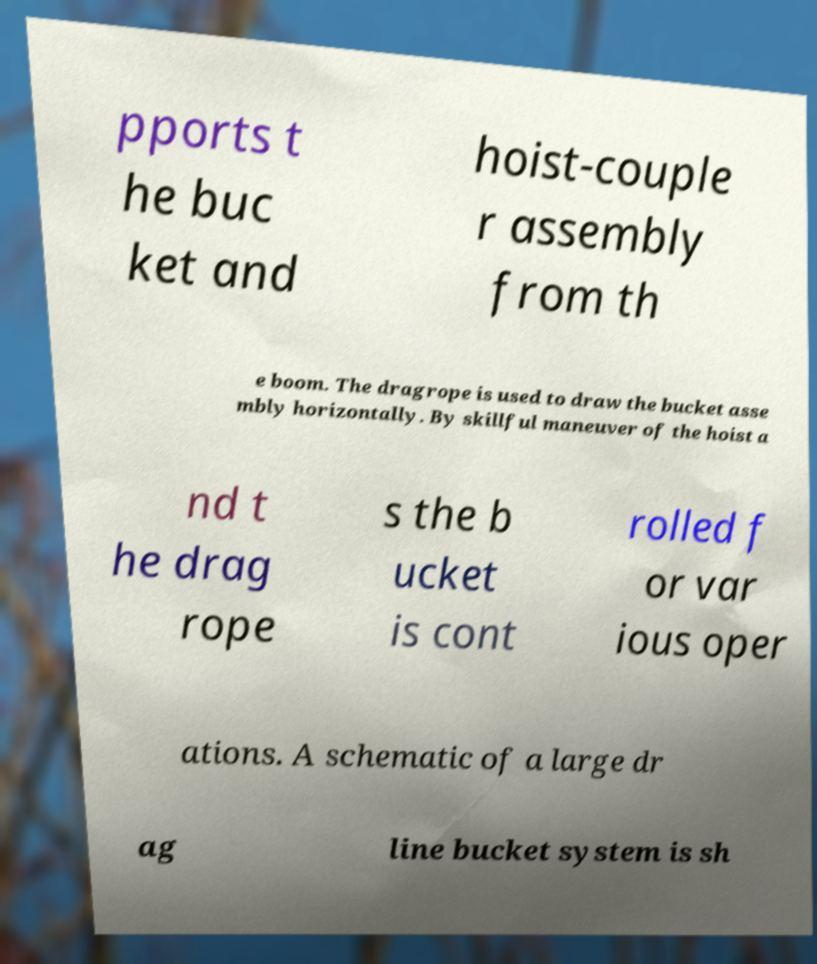What messages or text are displayed in this image? I need them in a readable, typed format. pports t he buc ket and hoist-couple r assembly from th e boom. The dragrope is used to draw the bucket asse mbly horizontally. By skillful maneuver of the hoist a nd t he drag rope s the b ucket is cont rolled f or var ious oper ations. A schematic of a large dr ag line bucket system is sh 